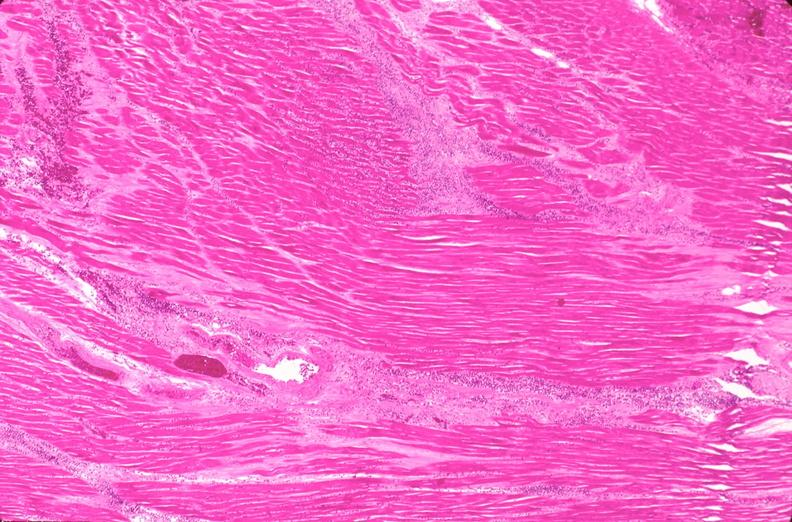what is present?
Answer the question using a single word or phrase. Cardiovascular 